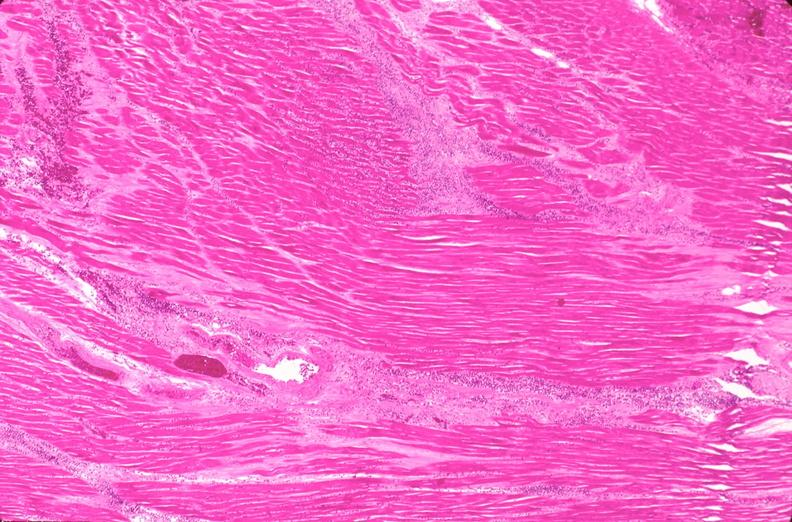what is present?
Answer the question using a single word or phrase. Cardiovascular 